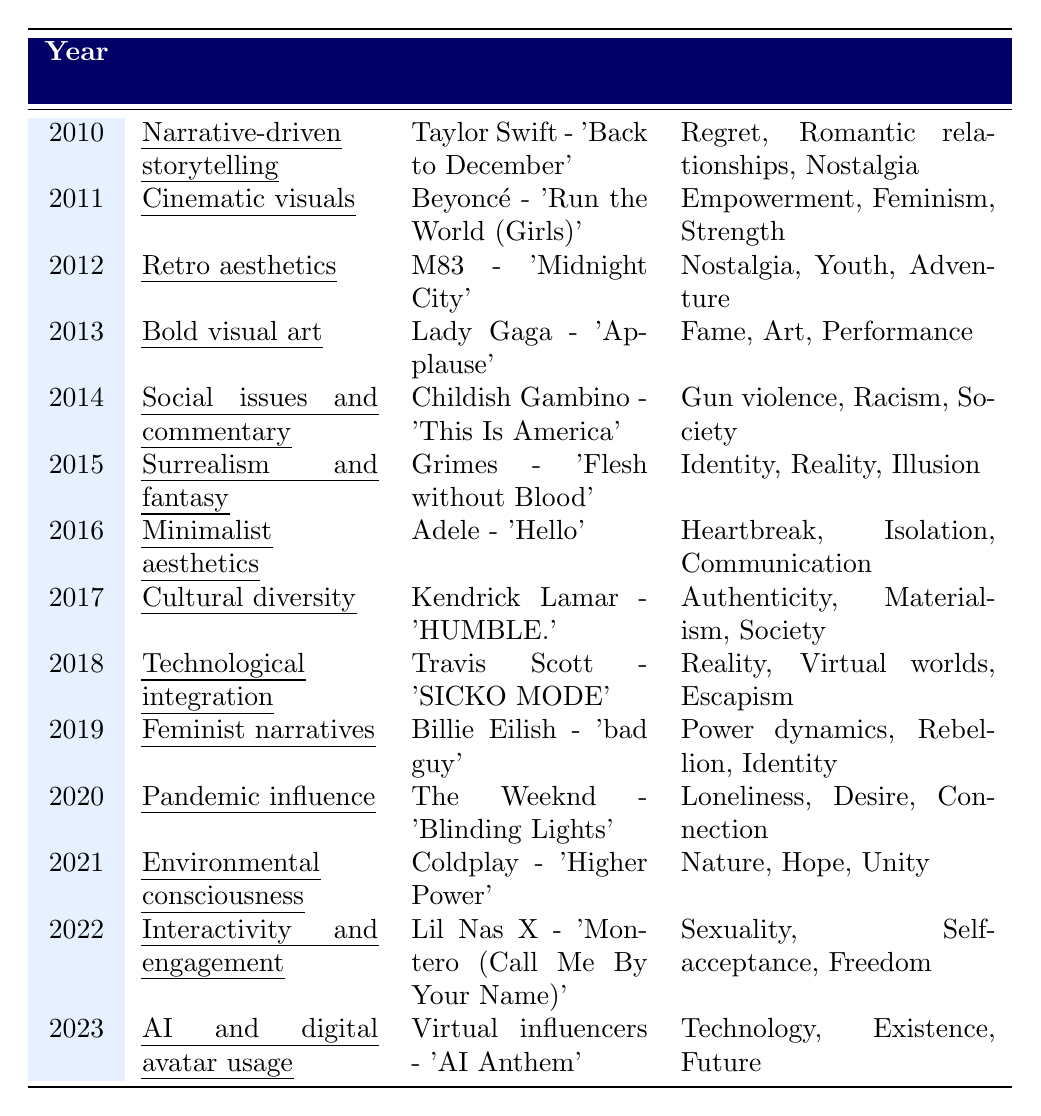What was the key concept in 2014? The table shows that the key concept for the year 2014 is "Social issues and commentary."
Answer: Social issues and commentary Which notable music video featured feminist narratives in 2019? According to the table, the notable music video for feminist narratives in 2019 is "Billie Eilish - 'bad guy'."
Answer: Billie Eilish - 'bad guy' How many years from 2010 to 2023 showcased the theme of nostalgia? The years that showcased the theme of nostalgia are 2010, 2012, and 2020, making a total of 3 instances in that range.
Answer: 3 Is "Cinematic visuals" associated with empowerment themes? Yes, the table indicates that "Cinematic visuals" from 2011 is linked to themes of empowerment, feminism, and strength.
Answer: Yes In which year did "Technological integration" become a key concept? The table shows that "Technological integration" became a key concept in 2018.
Answer: 2018 What is the notable music video from 2015, and what themes does it explore? The notable music video from 2015 is "Grimes - 'Flesh without Blood'," which explores themes of identity, reality, and illusion.
Answer: Grimes - 'Flesh without Blood'; themes of identity, reality, and illusion How many of the notable music videos explore themes of society, and can you name them? The table lists two notable music videos that explore themes of society: "Childish Gambino - 'This Is America'" (2014) and "Kendrick Lamar - 'HUMBLE.'" (2017).
Answer: 2; "This Is America," "HUMBLE." Which two consecutive years feature themes that revolve around technology and digital culture? The years 2022 ("Interactivity and engagement") and 2023 ("AI and digital avatar usage") focus on technology and digital culture, indicating a trend in those years.
Answer: 2022 and 2023 What is the average number of themes explored in the notable music videos from 2010 to 2013? Counting the themes from 2010 (3), 2011 (3), 2012 (3), and 2013 (3) gives a total of 12 themes across 4 years, leading to an average of 12/4 = 3 themes explored.
Answer: 3 In what way did the overall themes progress from 2010 to 2023? The themes progressed from personal-oriented themes (like nostalgia and relationships) to broader social issues and technological influences, indicating an evolution in focus over the years.
Answer: Evolved from personal to broader social and technological themes 